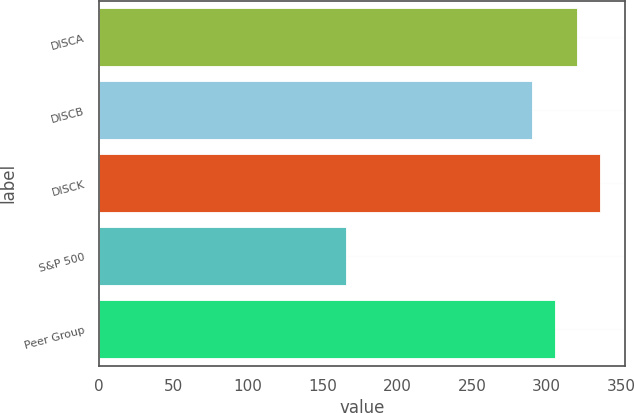Convert chart to OTSL. <chart><loc_0><loc_0><loc_500><loc_500><bar_chart><fcel>DISCA<fcel>DISCB<fcel>DISCK<fcel>S&P 500<fcel>Peer Group<nl><fcel>320.49<fcel>290.4<fcel>335.54<fcel>165.76<fcel>305.44<nl></chart> 